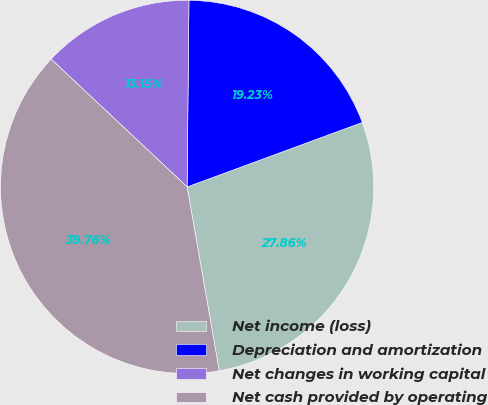Convert chart to OTSL. <chart><loc_0><loc_0><loc_500><loc_500><pie_chart><fcel>Net income (loss)<fcel>Depreciation and amortization<fcel>Net changes in working capital<fcel>Net cash provided by operating<nl><fcel>27.86%<fcel>19.23%<fcel>13.15%<fcel>39.76%<nl></chart> 